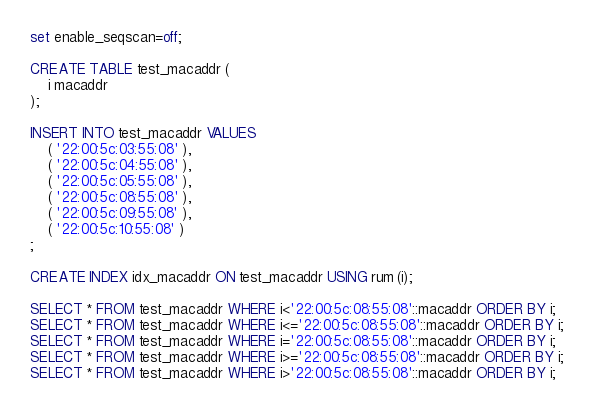Convert code to text. <code><loc_0><loc_0><loc_500><loc_500><_SQL_>set enable_seqscan=off;

CREATE TABLE test_macaddr (
	i macaddr
);

INSERT INTO test_macaddr VALUES
	( '22:00:5c:03:55:08' ),
	( '22:00:5c:04:55:08' ),
	( '22:00:5c:05:55:08' ),
	( '22:00:5c:08:55:08' ),
	( '22:00:5c:09:55:08' ),
	( '22:00:5c:10:55:08' )
;

CREATE INDEX idx_macaddr ON test_macaddr USING rum (i);

SELECT * FROM test_macaddr WHERE i<'22:00:5c:08:55:08'::macaddr ORDER BY i;
SELECT * FROM test_macaddr WHERE i<='22:00:5c:08:55:08'::macaddr ORDER BY i;
SELECT * FROM test_macaddr WHERE i='22:00:5c:08:55:08'::macaddr ORDER BY i;
SELECT * FROM test_macaddr WHERE i>='22:00:5c:08:55:08'::macaddr ORDER BY i;
SELECT * FROM test_macaddr WHERE i>'22:00:5c:08:55:08'::macaddr ORDER BY i;
</code> 